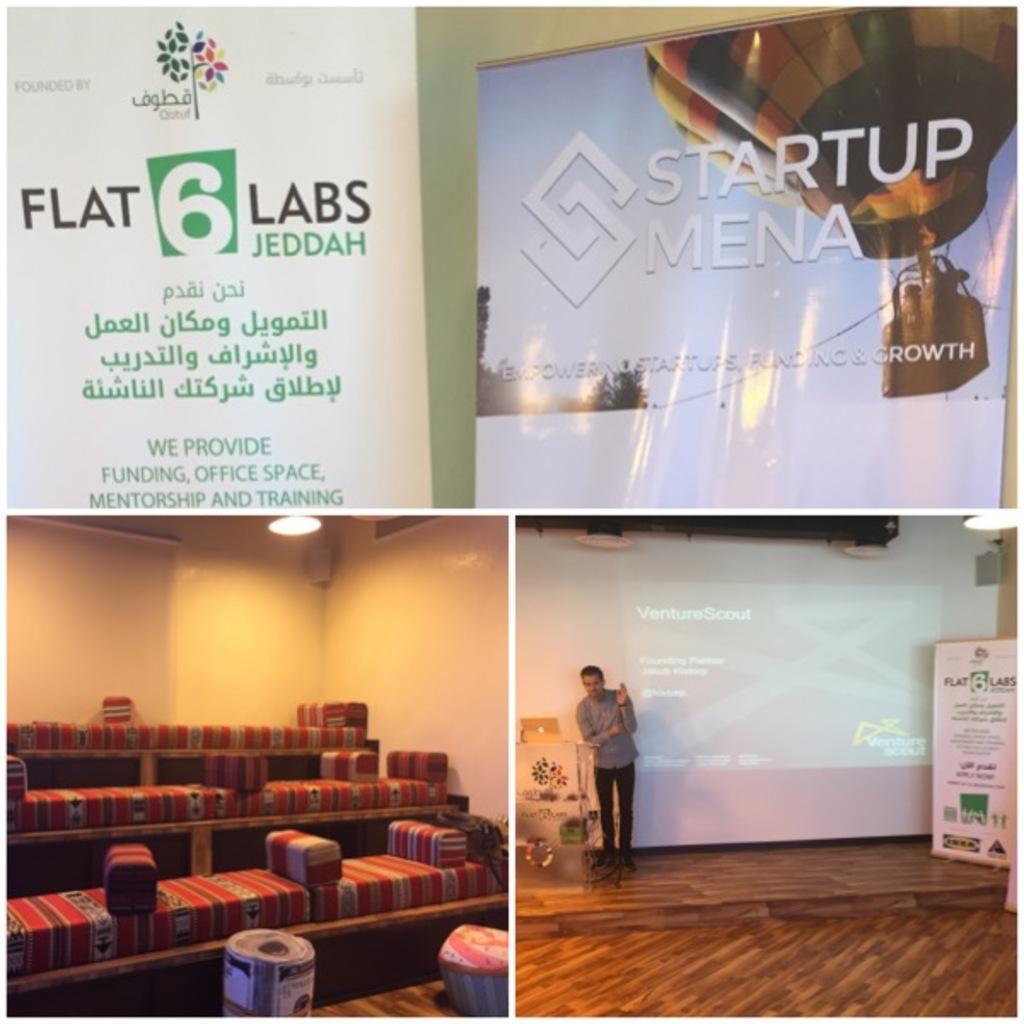Could you give a brief overview of what you see in this image? As we can see in the image there are banners, screen, sofas, wall and a person standing over here. 